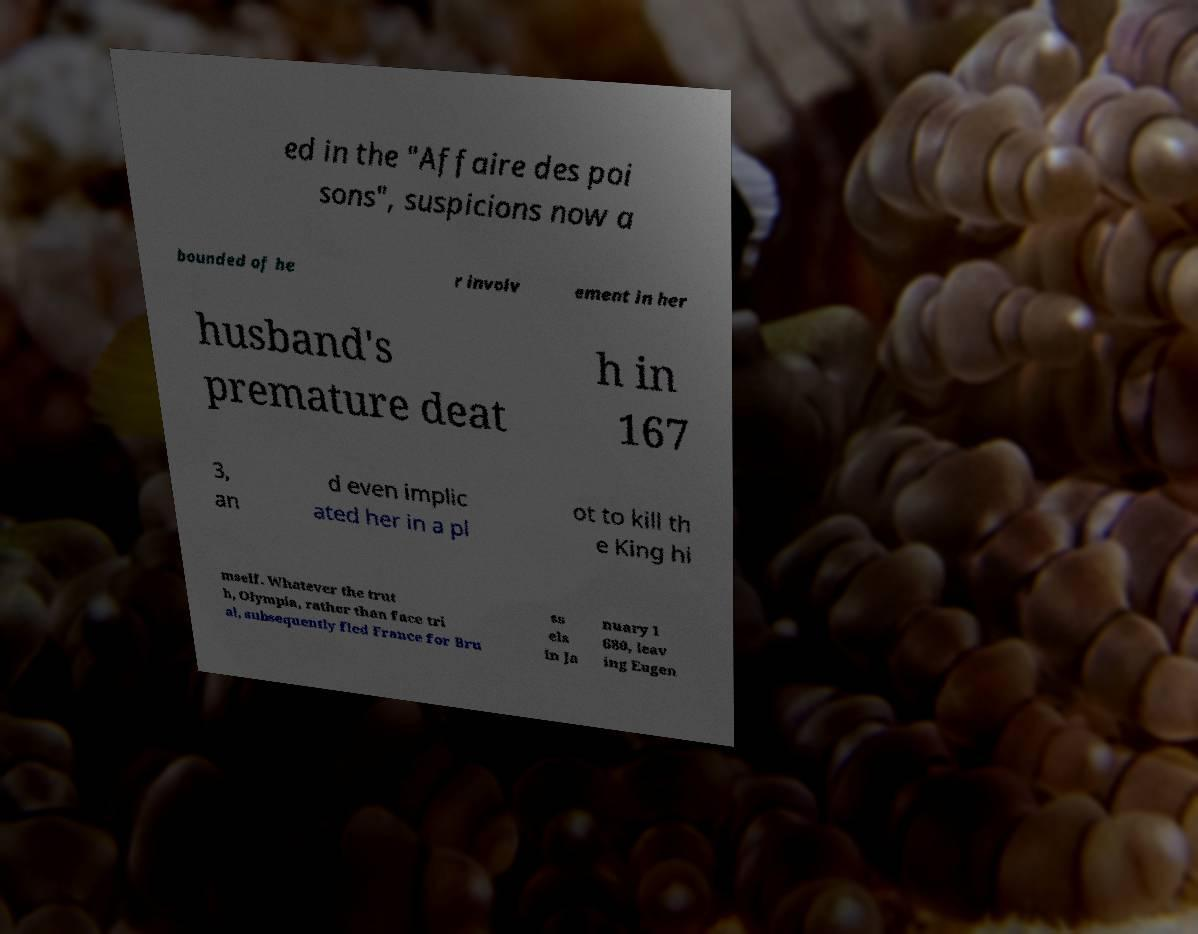Could you assist in decoding the text presented in this image and type it out clearly? ed in the "Affaire des poi sons", suspicions now a bounded of he r involv ement in her husband's premature deat h in 167 3, an d even implic ated her in a pl ot to kill th e King hi mself. Whatever the trut h, Olympia, rather than face tri al, subsequently fled France for Bru ss els in Ja nuary 1 680, leav ing Eugen 